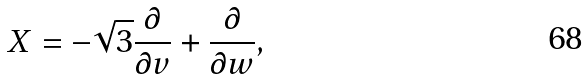Convert formula to latex. <formula><loc_0><loc_0><loc_500><loc_500>X = - \sqrt { 3 } \frac { \partial } { \partial v } + \frac { \partial } { \partial w } ,</formula> 